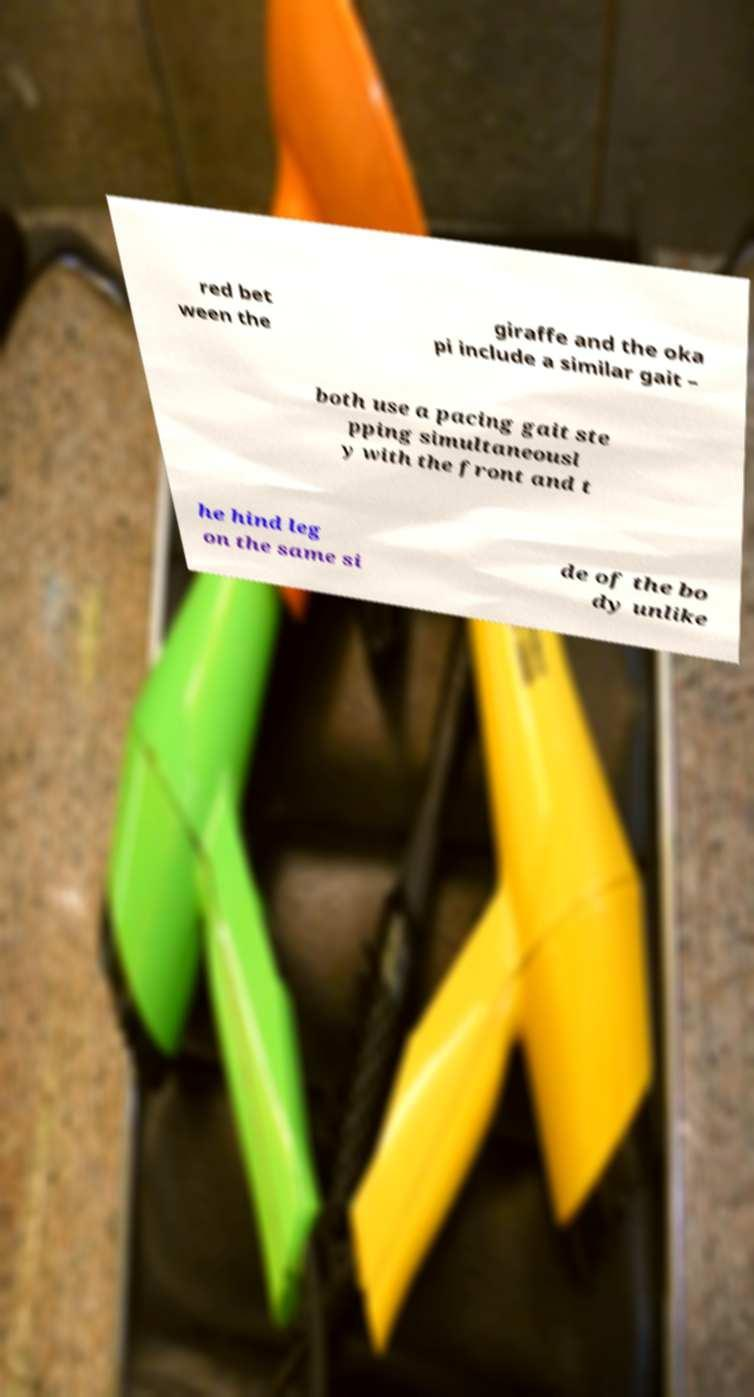Can you read and provide the text displayed in the image?This photo seems to have some interesting text. Can you extract and type it out for me? red bet ween the giraffe and the oka pi include a similar gait – both use a pacing gait ste pping simultaneousl y with the front and t he hind leg on the same si de of the bo dy unlike 